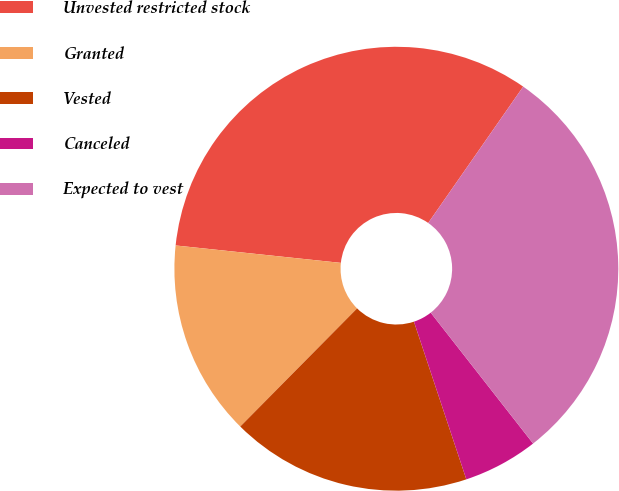<chart> <loc_0><loc_0><loc_500><loc_500><pie_chart><fcel>Unvested restricted stock<fcel>Granted<fcel>Vested<fcel>Canceled<fcel>Expected to vest<nl><fcel>33.01%<fcel>14.26%<fcel>17.52%<fcel>5.46%<fcel>29.75%<nl></chart> 